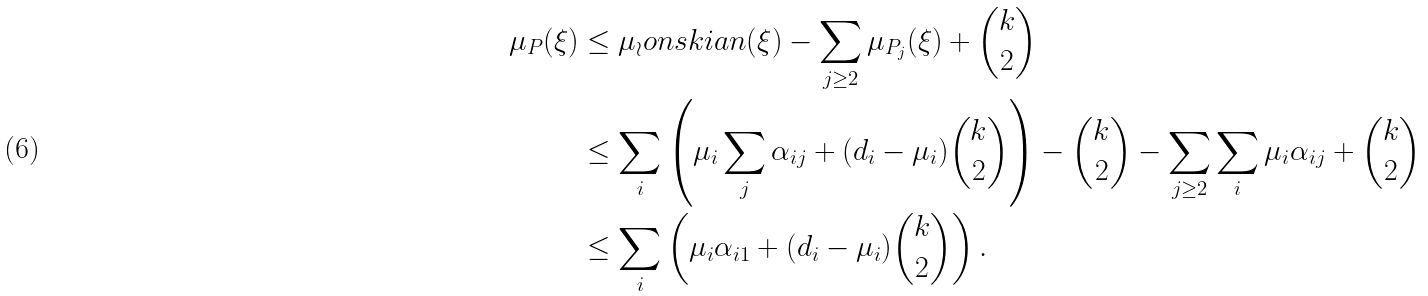Convert formula to latex. <formula><loc_0><loc_0><loc_500><loc_500>\mu _ { P } ( \xi ) & \leq \mu _ { \wr } o n s k i a n ( \xi ) - \sum _ { j \geq 2 } \mu _ { P _ { j } } ( \xi ) + \binom { k } { 2 } \\ & \leq \sum _ { i } \left ( \mu _ { i } \sum _ { j } \alpha _ { i j } + ( d _ { i } - \mu _ { i } ) \binom { k } { 2 } \right ) - \binom { k } { 2 } - \sum _ { j \geq 2 } \sum _ { i } \mu _ { i } \alpha _ { i j } + \binom { k } { 2 } \\ & \leq \sum _ { i } \left ( \mu _ { i } \alpha _ { i 1 } + ( d _ { i } - \mu _ { i } ) \binom { k } { 2 } \right ) .</formula> 